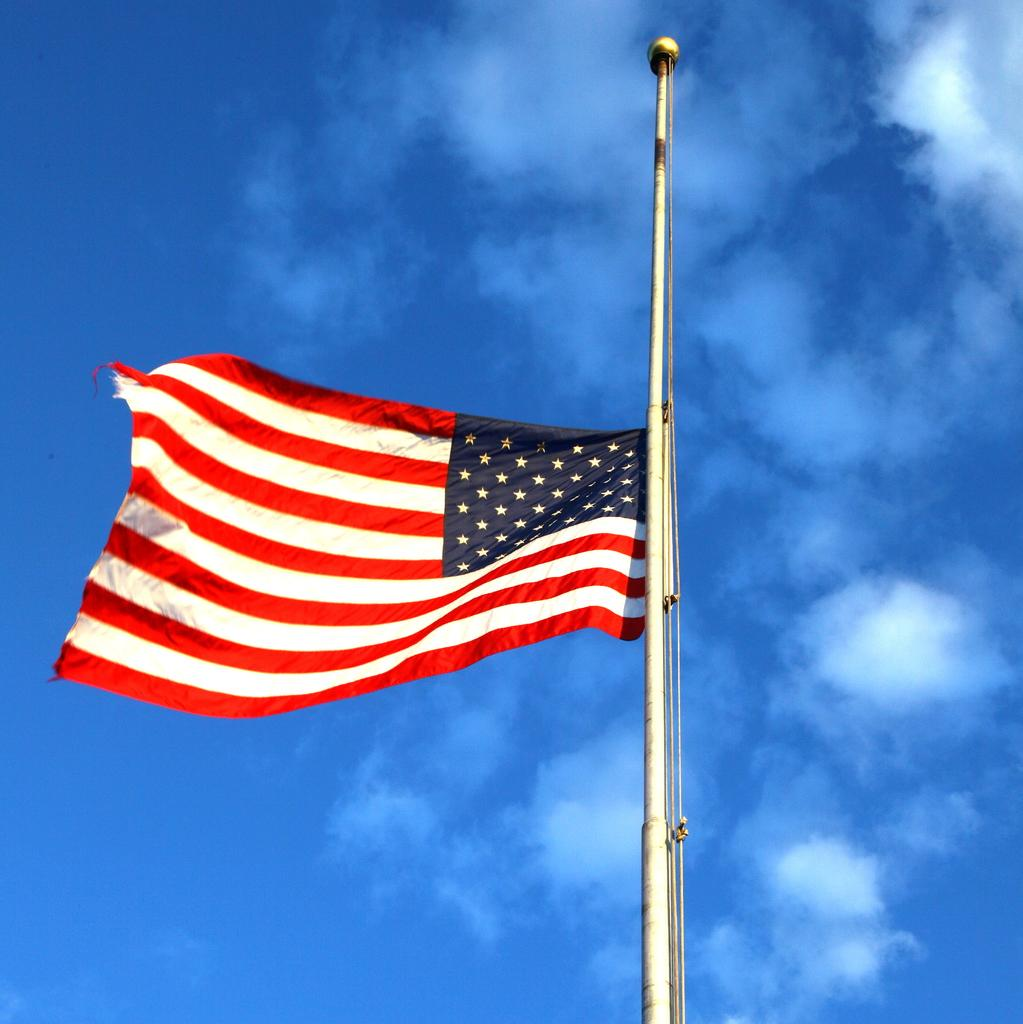What is the main object in the image? There is a flag in the image. What is the flag attached to? The flag is attached to a pole in the image. What can be seen in the background of the image? The sky is visible in the background of the image. Can you see any rays of sunlight shining through the flag in the image? There is no mention of sunlight or rays in the provided facts, so we cannot determine if they are present in the image. 